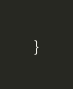Convert code to text. <code><loc_0><loc_0><loc_500><loc_500><_JavaScript_>}
</code> 